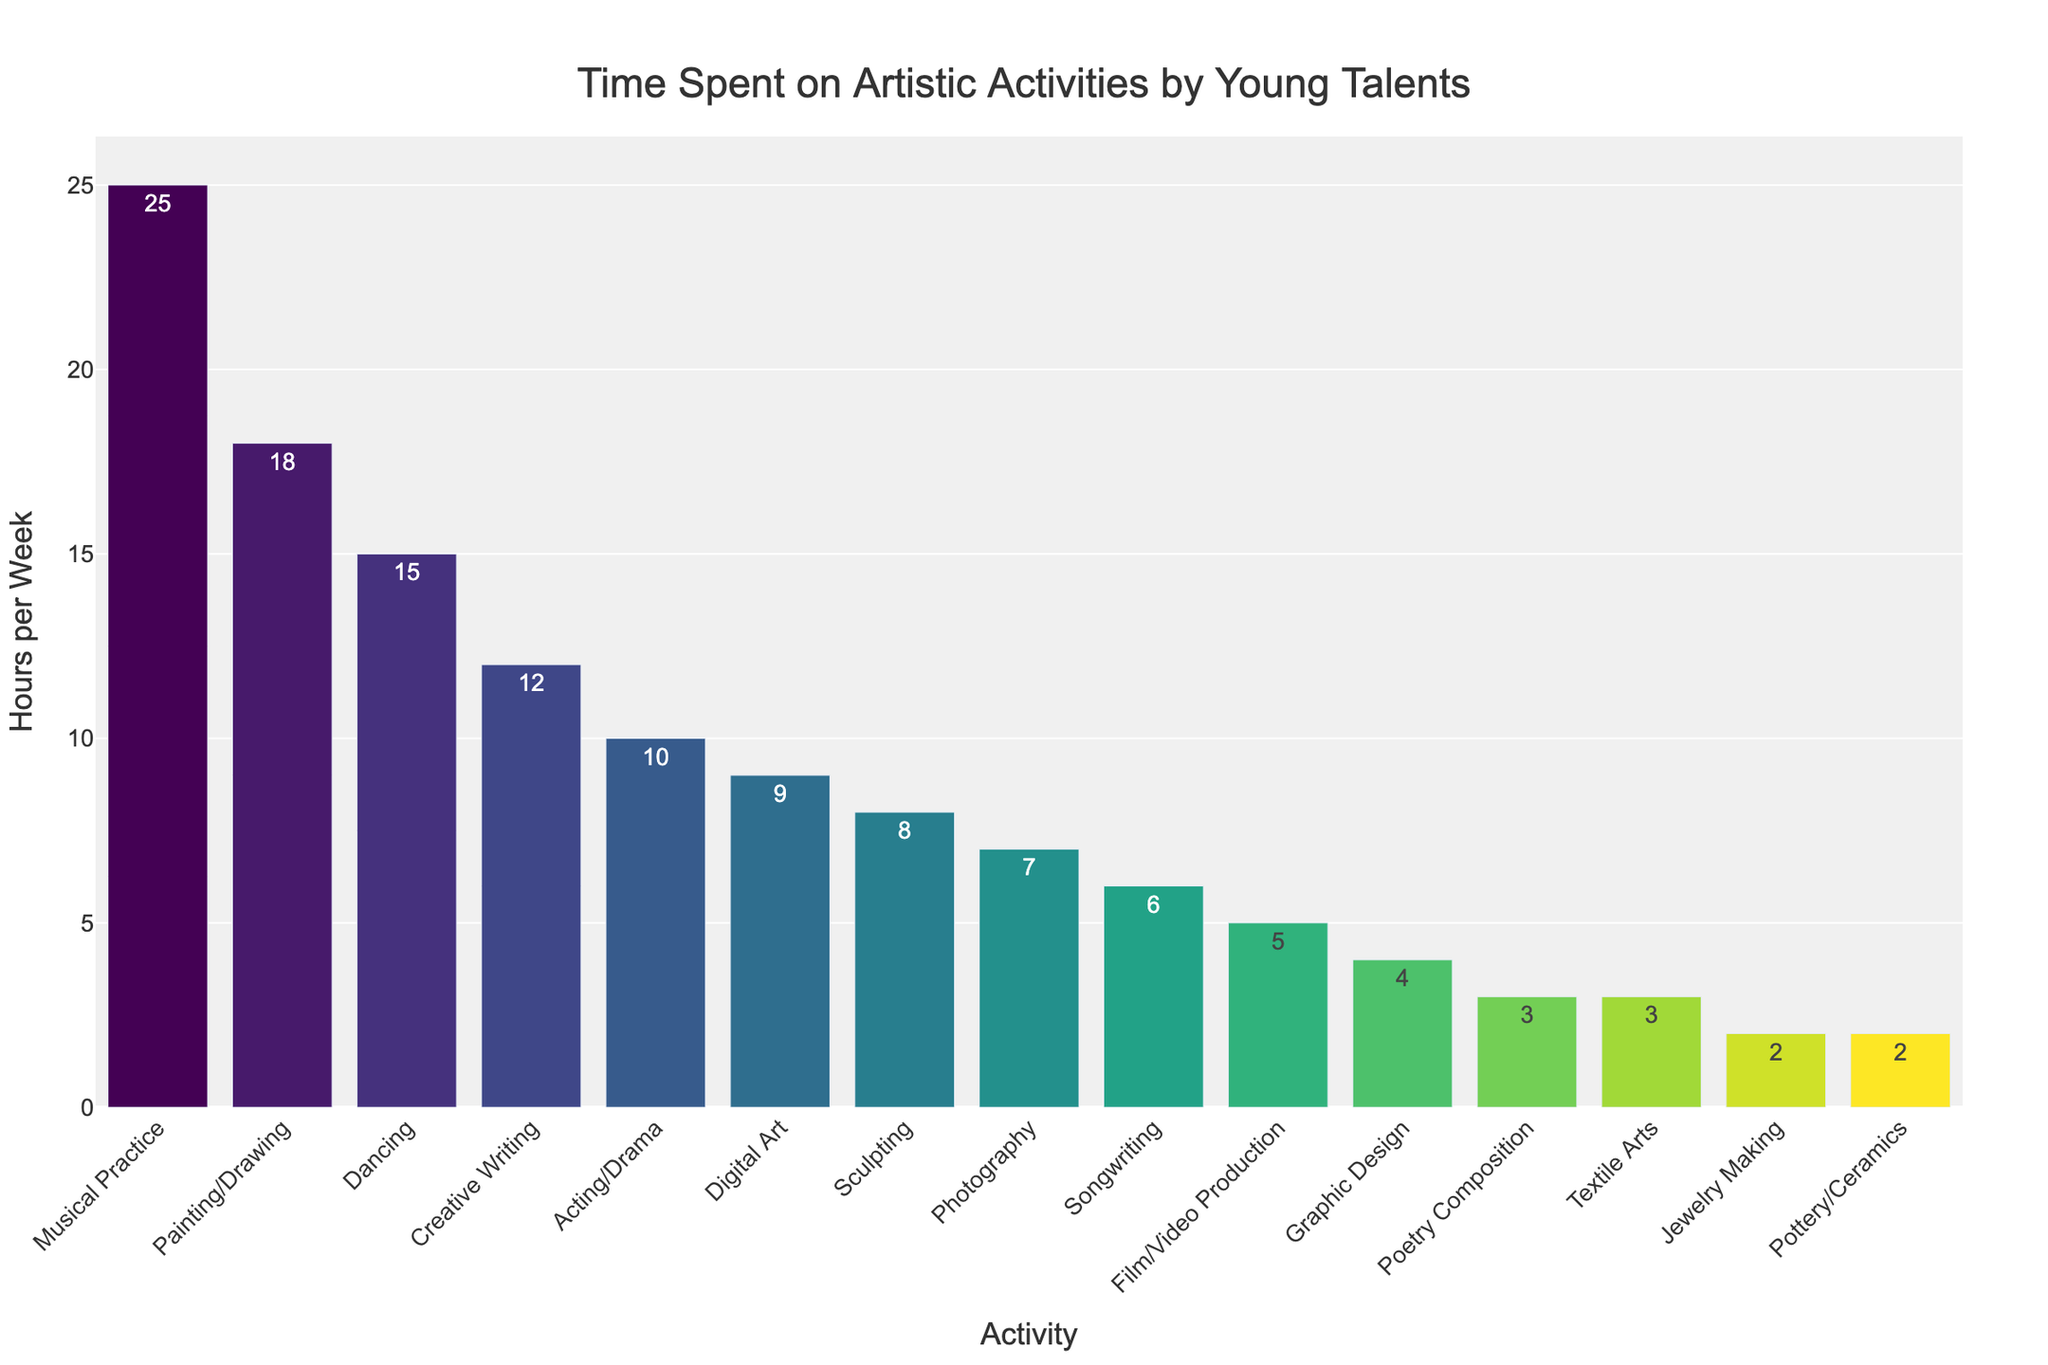Which activity do young talents spend the most time on in a typical week? The tallest bar in the chart represents the activity that occupies the most time, which is "Musical Practice" with a height indicating 25 hours per week.
Answer: Musical Practice How many more hours per week do young talents spend on Musical Practice compared to Creative Writing? Find the hours for both activities: Musical Practice is 25 hours, and Creative Writing is 12 hours. Calculate the difference: 25 - 12 = 13.
Answer: 13 Which has fewer hours, Digital Art or Photography, and by how much? According to the chart, Digital Art is 9 hours, and Photography is 7 hours. Digital Art has more hours. The difference is 9 - 7 = 2 hours.
Answer: Photography, by 2 hours What is the total amount of time spent on Painting/Drawing, Dancing, and Acting/Drama in a typical week? Sum the individual hours for these activities: Painting/Drawing (18 hours), Dancing (15 hours), and Acting/Drama (10 hours). The total is 18 + 15 + 10 = 43 hours.
Answer: 43 hours Which activity occupies the median time among all listed activities? Count the number of activities: 15. The median is the 8th value when sorted. The sorted list shows Digital Art at 9 hours.
Answer: Digital Art Do young talents spend more time on Poetry Composition or Pottery/Ceramics? Compare the heights of the bars for Poetry Composition (3 hours) and Pottery/Ceramics (2 hours). Poetry Composition is greater.
Answer: Poetry Composition Calculate the average time spent on the activities: Graphic Design, Jewelry Making, and Songwriting? Sum the hours for these activities: Graphic Design (4 hours), Jewelry Making (2 hours), and Songwriting (6 hours). The total is 4 + 2 + 6 = 12, and the average is 12 / 3 = 4 hours per week.
Answer: 4 hours How many activities have a time dedication of less than 10 hours per week? Identify and count bars with heights less than 10 hours, which are Sculpting, Photography, Digital Art, Songwriting, Film/Video Production, Graphic Design, Poetry Composition, Jewelry Making, Textile Arts, and Pottery/Ceramics. There are 10 activities.
Answer: 10 